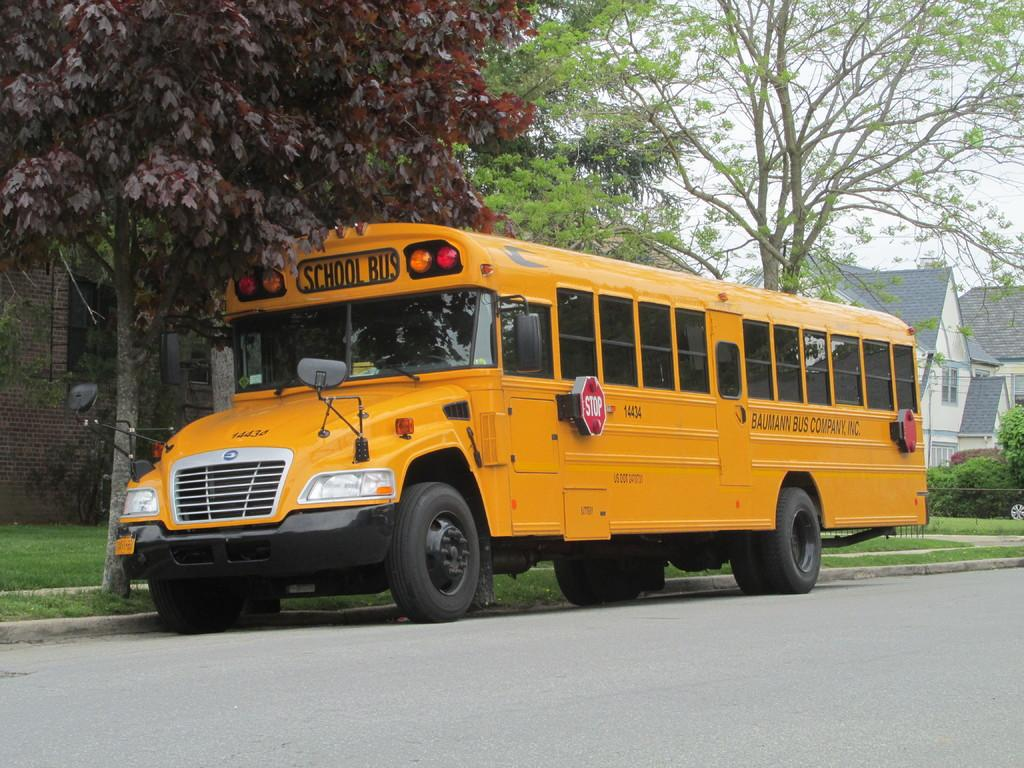What type of vehicle is on the road in the image? There is a bus on the road in the image. What can be seen at the side of the road? There is grass, a bicycle, trees, and a building at the side of the road. What is visible at the top of the image? The sky is visible at the top of the image. Can you see a magic plane carrying a crate in the image? No, there is no magic plane or crate present in the image. 